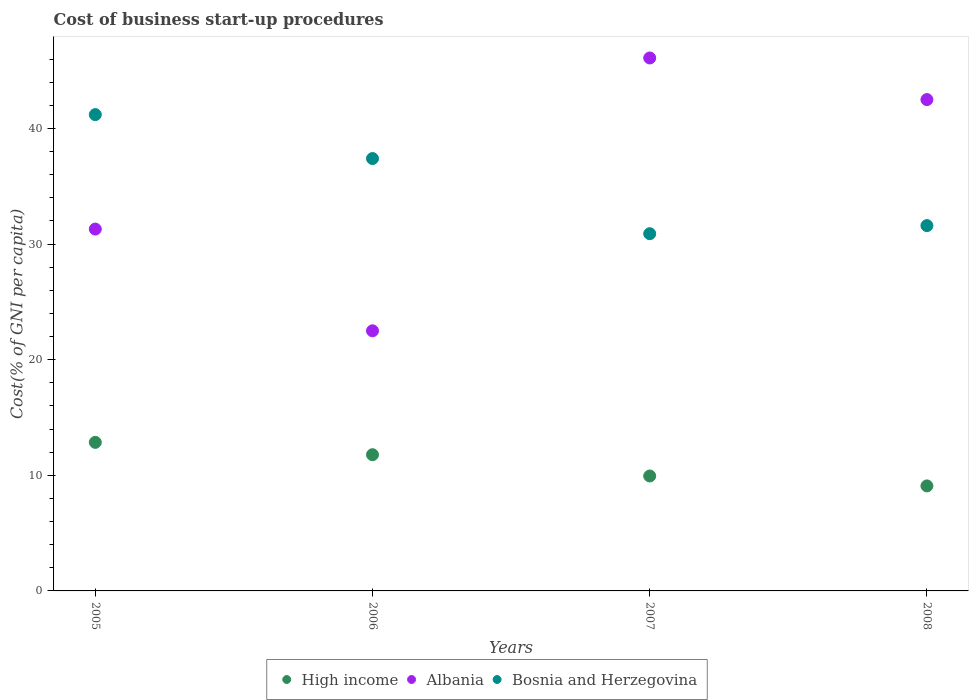How many different coloured dotlines are there?
Your response must be concise. 3. Is the number of dotlines equal to the number of legend labels?
Provide a succinct answer. Yes. What is the cost of business start-up procedures in High income in 2005?
Offer a very short reply. 12.85. Across all years, what is the maximum cost of business start-up procedures in High income?
Your response must be concise. 12.85. Across all years, what is the minimum cost of business start-up procedures in High income?
Your response must be concise. 9.08. In which year was the cost of business start-up procedures in Bosnia and Herzegovina maximum?
Provide a succinct answer. 2005. In which year was the cost of business start-up procedures in High income minimum?
Keep it short and to the point. 2008. What is the total cost of business start-up procedures in Albania in the graph?
Offer a terse response. 142.4. What is the difference between the cost of business start-up procedures in High income in 2005 and the cost of business start-up procedures in Albania in 2008?
Keep it short and to the point. -29.65. What is the average cost of business start-up procedures in Albania per year?
Make the answer very short. 35.6. In the year 2008, what is the difference between the cost of business start-up procedures in Albania and cost of business start-up procedures in High income?
Your response must be concise. 33.42. What is the ratio of the cost of business start-up procedures in Albania in 2005 to that in 2007?
Offer a very short reply. 0.68. Is the cost of business start-up procedures in Bosnia and Herzegovina in 2005 less than that in 2007?
Your response must be concise. No. Is the difference between the cost of business start-up procedures in Albania in 2005 and 2008 greater than the difference between the cost of business start-up procedures in High income in 2005 and 2008?
Your response must be concise. No. What is the difference between the highest and the second highest cost of business start-up procedures in High income?
Provide a short and direct response. 1.07. What is the difference between the highest and the lowest cost of business start-up procedures in High income?
Give a very brief answer. 3.77. In how many years, is the cost of business start-up procedures in High income greater than the average cost of business start-up procedures in High income taken over all years?
Keep it short and to the point. 2. Does the cost of business start-up procedures in High income monotonically increase over the years?
Keep it short and to the point. No. Is the cost of business start-up procedures in Bosnia and Herzegovina strictly greater than the cost of business start-up procedures in Albania over the years?
Make the answer very short. No. How many years are there in the graph?
Your answer should be compact. 4. What is the difference between two consecutive major ticks on the Y-axis?
Give a very brief answer. 10. Are the values on the major ticks of Y-axis written in scientific E-notation?
Your answer should be compact. No. Does the graph contain grids?
Offer a very short reply. No. Where does the legend appear in the graph?
Provide a short and direct response. Bottom center. What is the title of the graph?
Provide a succinct answer. Cost of business start-up procedures. What is the label or title of the Y-axis?
Make the answer very short. Cost(% of GNI per capita). What is the Cost(% of GNI per capita) of High income in 2005?
Ensure brevity in your answer.  12.85. What is the Cost(% of GNI per capita) of Albania in 2005?
Offer a very short reply. 31.3. What is the Cost(% of GNI per capita) in Bosnia and Herzegovina in 2005?
Offer a very short reply. 41.2. What is the Cost(% of GNI per capita) of High income in 2006?
Give a very brief answer. 11.78. What is the Cost(% of GNI per capita) in Albania in 2006?
Give a very brief answer. 22.5. What is the Cost(% of GNI per capita) of Bosnia and Herzegovina in 2006?
Provide a succinct answer. 37.4. What is the Cost(% of GNI per capita) of High income in 2007?
Your answer should be compact. 9.94. What is the Cost(% of GNI per capita) in Albania in 2007?
Your answer should be compact. 46.1. What is the Cost(% of GNI per capita) in Bosnia and Herzegovina in 2007?
Give a very brief answer. 30.9. What is the Cost(% of GNI per capita) in High income in 2008?
Offer a very short reply. 9.08. What is the Cost(% of GNI per capita) of Albania in 2008?
Give a very brief answer. 42.5. What is the Cost(% of GNI per capita) of Bosnia and Herzegovina in 2008?
Make the answer very short. 31.6. Across all years, what is the maximum Cost(% of GNI per capita) in High income?
Your response must be concise. 12.85. Across all years, what is the maximum Cost(% of GNI per capita) in Albania?
Give a very brief answer. 46.1. Across all years, what is the maximum Cost(% of GNI per capita) in Bosnia and Herzegovina?
Provide a short and direct response. 41.2. Across all years, what is the minimum Cost(% of GNI per capita) in High income?
Provide a succinct answer. 9.08. Across all years, what is the minimum Cost(% of GNI per capita) of Albania?
Give a very brief answer. 22.5. Across all years, what is the minimum Cost(% of GNI per capita) in Bosnia and Herzegovina?
Give a very brief answer. 30.9. What is the total Cost(% of GNI per capita) in High income in the graph?
Keep it short and to the point. 43.66. What is the total Cost(% of GNI per capita) in Albania in the graph?
Keep it short and to the point. 142.4. What is the total Cost(% of GNI per capita) in Bosnia and Herzegovina in the graph?
Make the answer very short. 141.1. What is the difference between the Cost(% of GNI per capita) of High income in 2005 and that in 2006?
Ensure brevity in your answer.  1.07. What is the difference between the Cost(% of GNI per capita) in Albania in 2005 and that in 2006?
Your response must be concise. 8.8. What is the difference between the Cost(% of GNI per capita) in High income in 2005 and that in 2007?
Your answer should be very brief. 2.91. What is the difference between the Cost(% of GNI per capita) of Albania in 2005 and that in 2007?
Keep it short and to the point. -14.8. What is the difference between the Cost(% of GNI per capita) in High income in 2005 and that in 2008?
Ensure brevity in your answer.  3.77. What is the difference between the Cost(% of GNI per capita) of High income in 2006 and that in 2007?
Keep it short and to the point. 1.84. What is the difference between the Cost(% of GNI per capita) of Albania in 2006 and that in 2007?
Your answer should be compact. -23.6. What is the difference between the Cost(% of GNI per capita) of Bosnia and Herzegovina in 2006 and that in 2007?
Provide a short and direct response. 6.5. What is the difference between the Cost(% of GNI per capita) in High income in 2006 and that in 2008?
Give a very brief answer. 2.7. What is the difference between the Cost(% of GNI per capita) of Albania in 2006 and that in 2008?
Provide a succinct answer. -20. What is the difference between the Cost(% of GNI per capita) of High income in 2007 and that in 2008?
Offer a very short reply. 0.86. What is the difference between the Cost(% of GNI per capita) of Albania in 2007 and that in 2008?
Ensure brevity in your answer.  3.6. What is the difference between the Cost(% of GNI per capita) in Bosnia and Herzegovina in 2007 and that in 2008?
Your response must be concise. -0.7. What is the difference between the Cost(% of GNI per capita) in High income in 2005 and the Cost(% of GNI per capita) in Albania in 2006?
Offer a very short reply. -9.65. What is the difference between the Cost(% of GNI per capita) of High income in 2005 and the Cost(% of GNI per capita) of Bosnia and Herzegovina in 2006?
Make the answer very short. -24.55. What is the difference between the Cost(% of GNI per capita) of High income in 2005 and the Cost(% of GNI per capita) of Albania in 2007?
Ensure brevity in your answer.  -33.25. What is the difference between the Cost(% of GNI per capita) of High income in 2005 and the Cost(% of GNI per capita) of Bosnia and Herzegovina in 2007?
Give a very brief answer. -18.05. What is the difference between the Cost(% of GNI per capita) in High income in 2005 and the Cost(% of GNI per capita) in Albania in 2008?
Provide a short and direct response. -29.65. What is the difference between the Cost(% of GNI per capita) of High income in 2005 and the Cost(% of GNI per capita) of Bosnia and Herzegovina in 2008?
Your answer should be very brief. -18.75. What is the difference between the Cost(% of GNI per capita) in High income in 2006 and the Cost(% of GNI per capita) in Albania in 2007?
Provide a succinct answer. -34.32. What is the difference between the Cost(% of GNI per capita) in High income in 2006 and the Cost(% of GNI per capita) in Bosnia and Herzegovina in 2007?
Your response must be concise. -19.12. What is the difference between the Cost(% of GNI per capita) of Albania in 2006 and the Cost(% of GNI per capita) of Bosnia and Herzegovina in 2007?
Offer a very short reply. -8.4. What is the difference between the Cost(% of GNI per capita) in High income in 2006 and the Cost(% of GNI per capita) in Albania in 2008?
Offer a terse response. -30.72. What is the difference between the Cost(% of GNI per capita) of High income in 2006 and the Cost(% of GNI per capita) of Bosnia and Herzegovina in 2008?
Keep it short and to the point. -19.82. What is the difference between the Cost(% of GNI per capita) of Albania in 2006 and the Cost(% of GNI per capita) of Bosnia and Herzegovina in 2008?
Offer a very short reply. -9.1. What is the difference between the Cost(% of GNI per capita) in High income in 2007 and the Cost(% of GNI per capita) in Albania in 2008?
Give a very brief answer. -32.56. What is the difference between the Cost(% of GNI per capita) of High income in 2007 and the Cost(% of GNI per capita) of Bosnia and Herzegovina in 2008?
Offer a terse response. -21.66. What is the average Cost(% of GNI per capita) in High income per year?
Provide a short and direct response. 10.91. What is the average Cost(% of GNI per capita) in Albania per year?
Ensure brevity in your answer.  35.6. What is the average Cost(% of GNI per capita) of Bosnia and Herzegovina per year?
Your answer should be compact. 35.27. In the year 2005, what is the difference between the Cost(% of GNI per capita) in High income and Cost(% of GNI per capita) in Albania?
Ensure brevity in your answer.  -18.45. In the year 2005, what is the difference between the Cost(% of GNI per capita) in High income and Cost(% of GNI per capita) in Bosnia and Herzegovina?
Provide a succinct answer. -28.35. In the year 2005, what is the difference between the Cost(% of GNI per capita) in Albania and Cost(% of GNI per capita) in Bosnia and Herzegovina?
Your answer should be compact. -9.9. In the year 2006, what is the difference between the Cost(% of GNI per capita) in High income and Cost(% of GNI per capita) in Albania?
Offer a terse response. -10.72. In the year 2006, what is the difference between the Cost(% of GNI per capita) in High income and Cost(% of GNI per capita) in Bosnia and Herzegovina?
Provide a succinct answer. -25.62. In the year 2006, what is the difference between the Cost(% of GNI per capita) of Albania and Cost(% of GNI per capita) of Bosnia and Herzegovina?
Give a very brief answer. -14.9. In the year 2007, what is the difference between the Cost(% of GNI per capita) of High income and Cost(% of GNI per capita) of Albania?
Your response must be concise. -36.16. In the year 2007, what is the difference between the Cost(% of GNI per capita) in High income and Cost(% of GNI per capita) in Bosnia and Herzegovina?
Offer a terse response. -20.96. In the year 2007, what is the difference between the Cost(% of GNI per capita) in Albania and Cost(% of GNI per capita) in Bosnia and Herzegovina?
Your answer should be compact. 15.2. In the year 2008, what is the difference between the Cost(% of GNI per capita) in High income and Cost(% of GNI per capita) in Albania?
Your answer should be compact. -33.42. In the year 2008, what is the difference between the Cost(% of GNI per capita) of High income and Cost(% of GNI per capita) of Bosnia and Herzegovina?
Offer a terse response. -22.52. What is the ratio of the Cost(% of GNI per capita) in High income in 2005 to that in 2006?
Keep it short and to the point. 1.09. What is the ratio of the Cost(% of GNI per capita) of Albania in 2005 to that in 2006?
Offer a very short reply. 1.39. What is the ratio of the Cost(% of GNI per capita) of Bosnia and Herzegovina in 2005 to that in 2006?
Make the answer very short. 1.1. What is the ratio of the Cost(% of GNI per capita) of High income in 2005 to that in 2007?
Offer a terse response. 1.29. What is the ratio of the Cost(% of GNI per capita) in Albania in 2005 to that in 2007?
Provide a succinct answer. 0.68. What is the ratio of the Cost(% of GNI per capita) of High income in 2005 to that in 2008?
Provide a succinct answer. 1.41. What is the ratio of the Cost(% of GNI per capita) of Albania in 2005 to that in 2008?
Make the answer very short. 0.74. What is the ratio of the Cost(% of GNI per capita) of Bosnia and Herzegovina in 2005 to that in 2008?
Ensure brevity in your answer.  1.3. What is the ratio of the Cost(% of GNI per capita) in High income in 2006 to that in 2007?
Provide a short and direct response. 1.19. What is the ratio of the Cost(% of GNI per capita) of Albania in 2006 to that in 2007?
Provide a succinct answer. 0.49. What is the ratio of the Cost(% of GNI per capita) of Bosnia and Herzegovina in 2006 to that in 2007?
Provide a short and direct response. 1.21. What is the ratio of the Cost(% of GNI per capita) in High income in 2006 to that in 2008?
Provide a succinct answer. 1.3. What is the ratio of the Cost(% of GNI per capita) in Albania in 2006 to that in 2008?
Give a very brief answer. 0.53. What is the ratio of the Cost(% of GNI per capita) in Bosnia and Herzegovina in 2006 to that in 2008?
Your answer should be compact. 1.18. What is the ratio of the Cost(% of GNI per capita) in High income in 2007 to that in 2008?
Your answer should be very brief. 1.09. What is the ratio of the Cost(% of GNI per capita) of Albania in 2007 to that in 2008?
Keep it short and to the point. 1.08. What is the ratio of the Cost(% of GNI per capita) of Bosnia and Herzegovina in 2007 to that in 2008?
Your answer should be compact. 0.98. What is the difference between the highest and the second highest Cost(% of GNI per capita) of High income?
Ensure brevity in your answer.  1.07. What is the difference between the highest and the second highest Cost(% of GNI per capita) in Albania?
Give a very brief answer. 3.6. What is the difference between the highest and the second highest Cost(% of GNI per capita) of Bosnia and Herzegovina?
Your answer should be compact. 3.8. What is the difference between the highest and the lowest Cost(% of GNI per capita) of High income?
Make the answer very short. 3.77. What is the difference between the highest and the lowest Cost(% of GNI per capita) of Albania?
Provide a succinct answer. 23.6. What is the difference between the highest and the lowest Cost(% of GNI per capita) in Bosnia and Herzegovina?
Your response must be concise. 10.3. 